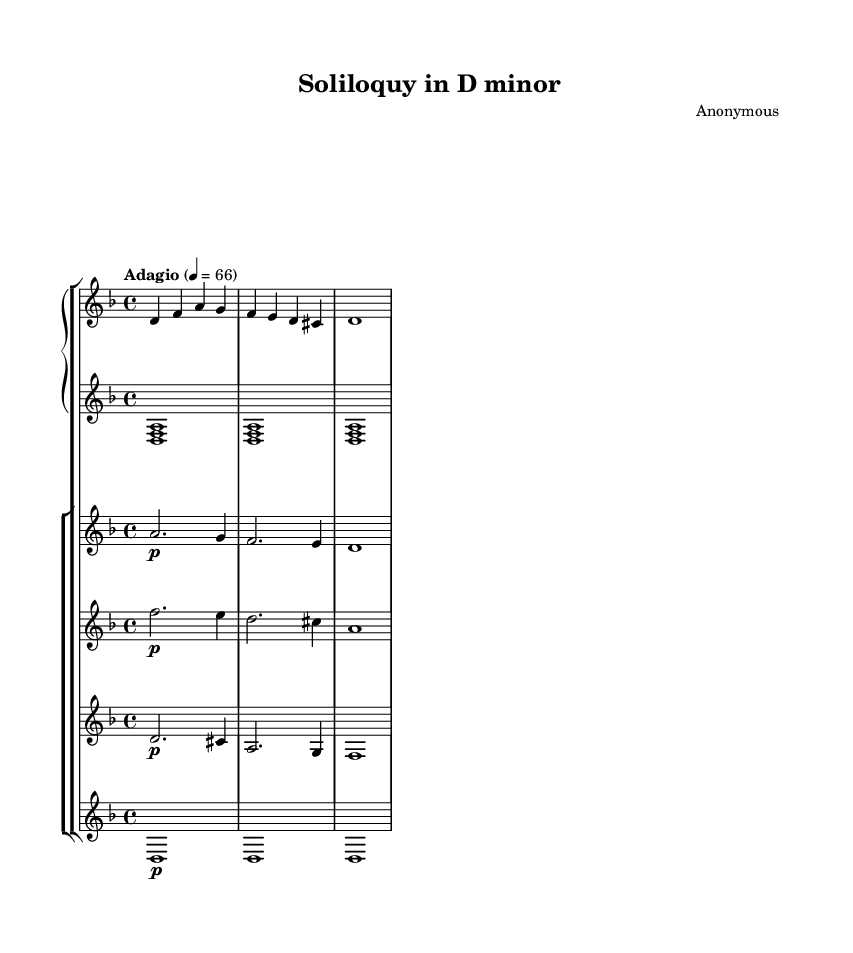What is the key signature of this music? The key signature is indicated at the beginning of the staff. In this case, there are two flats, which corresponds to the key of D minor.
Answer: D minor What is the time signature of this music? The time signature is located at the start of the piece, represented by the numbers above the staff. It shows that there are four beats in each measure, indicated as 4/4.
Answer: 4/4 What is the tempo marking for this music? The tempo marking is placed below the title and indicates the speed of the piece. Here it is marked as "Adagio," which generally implies a slow tempo, specifically set at 4 beats per minute = 66.
Answer: Adagio How many measures are indicated in the piano right hand part? The piano right hand part contains a specific amount of measures indicated by the bar lines. In this excerpt, only 3 measures can be counted.
Answer: 3 What dynamic marking is present in the violin I part? In the violin I part, a dynamic marking "p" is visible, indicating that it should be played piano, which means softly.
Answer: piano Which instrument plays the longest sustained note in the provided music? By looking at the different parts, the cello section plays a whole note sustained through the measures, making it the longest.
Answer: cello What unique musical theme is prevalent in this piece? The music expresses themes of melancholy and introspection, as suggested by its minor key and the slow, reflective tempo.
Answer: melancholy and introspection 